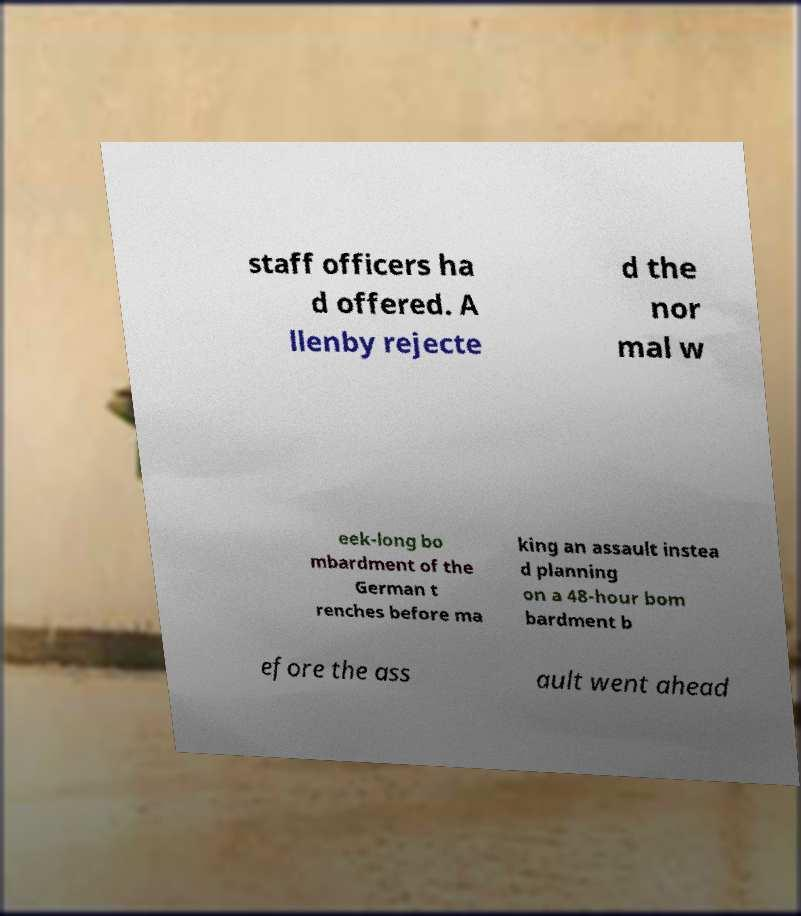Can you read and provide the text displayed in the image?This photo seems to have some interesting text. Can you extract and type it out for me? staff officers ha d offered. A llenby rejecte d the nor mal w eek-long bo mbardment of the German t renches before ma king an assault instea d planning on a 48-hour bom bardment b efore the ass ault went ahead 